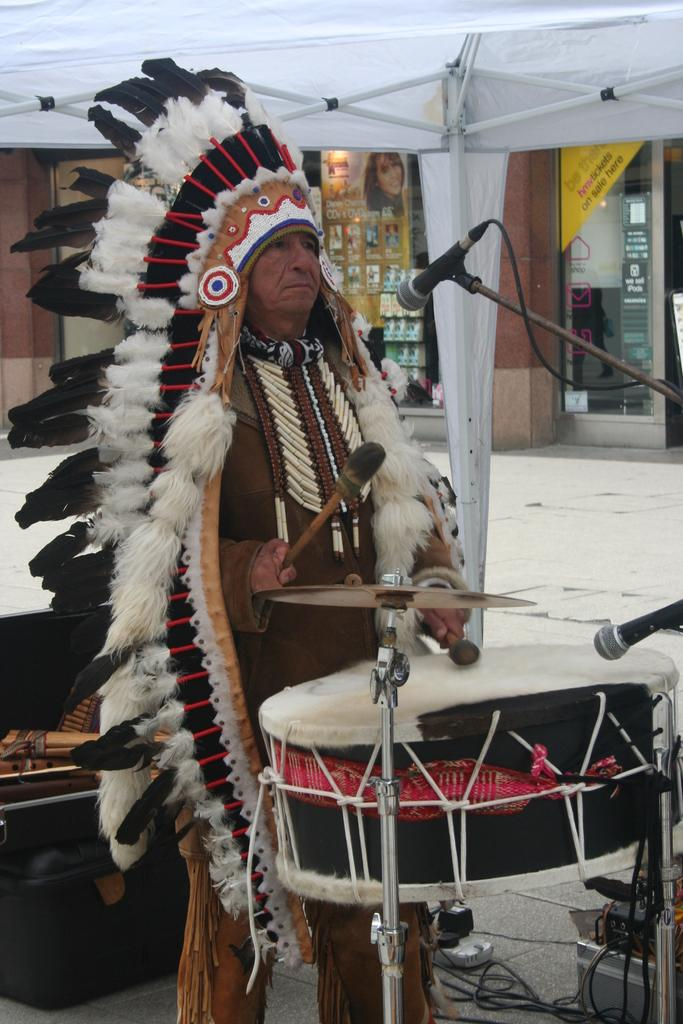What is the person in the image doing? The person is playing drums. Where is the person playing drums located? The person is under a tent. What can be seen in the background of the image? There is a building visible in the background of the image. What objects are at the bottom of the image? There is a box and a wire at the bottom of the image. Can you see a toad hopping near the building in the image? There is no toad present in the image. Is the person playing drums in a cave in the image? The image does not depict a cave; the person is under a tent. 